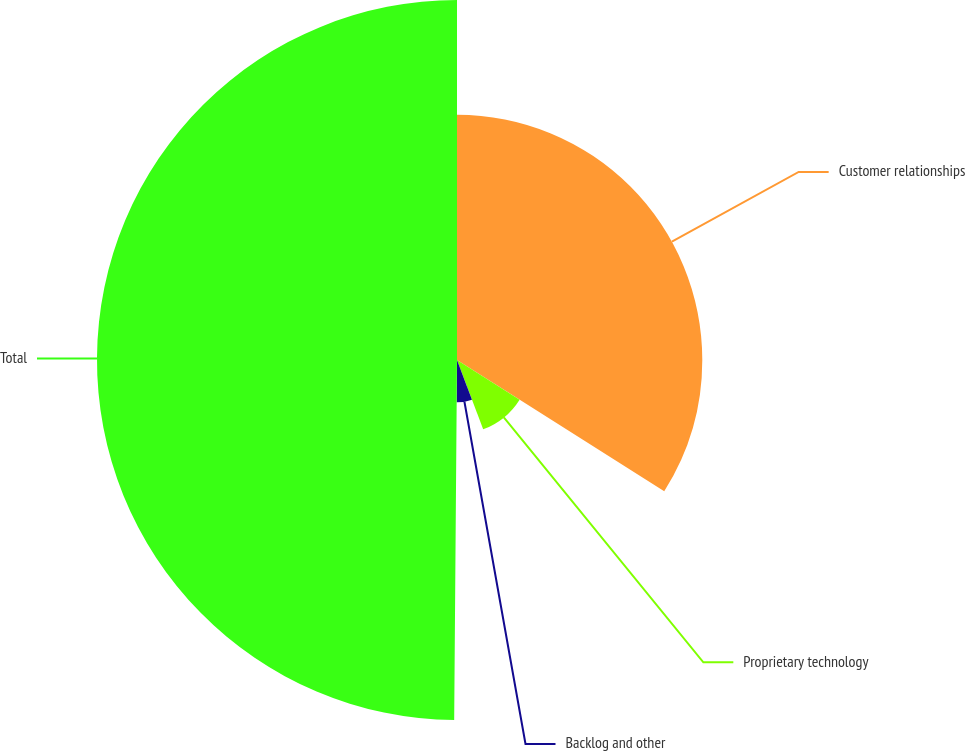Convert chart. <chart><loc_0><loc_0><loc_500><loc_500><pie_chart><fcel>Customer relationships<fcel>Proprietary technology<fcel>Backlog and other<fcel>Total<nl><fcel>33.98%<fcel>10.27%<fcel>5.87%<fcel>49.87%<nl></chart> 